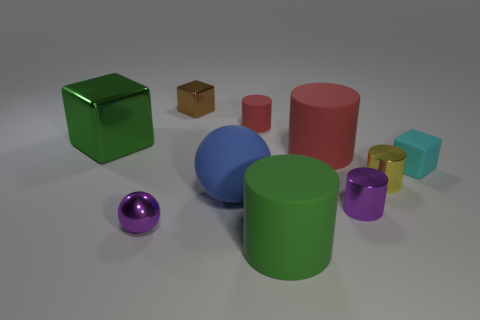Subtract all large red rubber cylinders. How many cylinders are left? 4 Subtract all purple cylinders. How many cylinders are left? 4 Subtract all cyan cylinders. Subtract all brown spheres. How many cylinders are left? 5 Subtract all cubes. How many objects are left? 7 Add 3 big blue rubber balls. How many big blue rubber balls are left? 4 Add 7 big blue spheres. How many big blue spheres exist? 8 Subtract 1 green cubes. How many objects are left? 9 Subtract all green shiny things. Subtract all large gray rubber things. How many objects are left? 9 